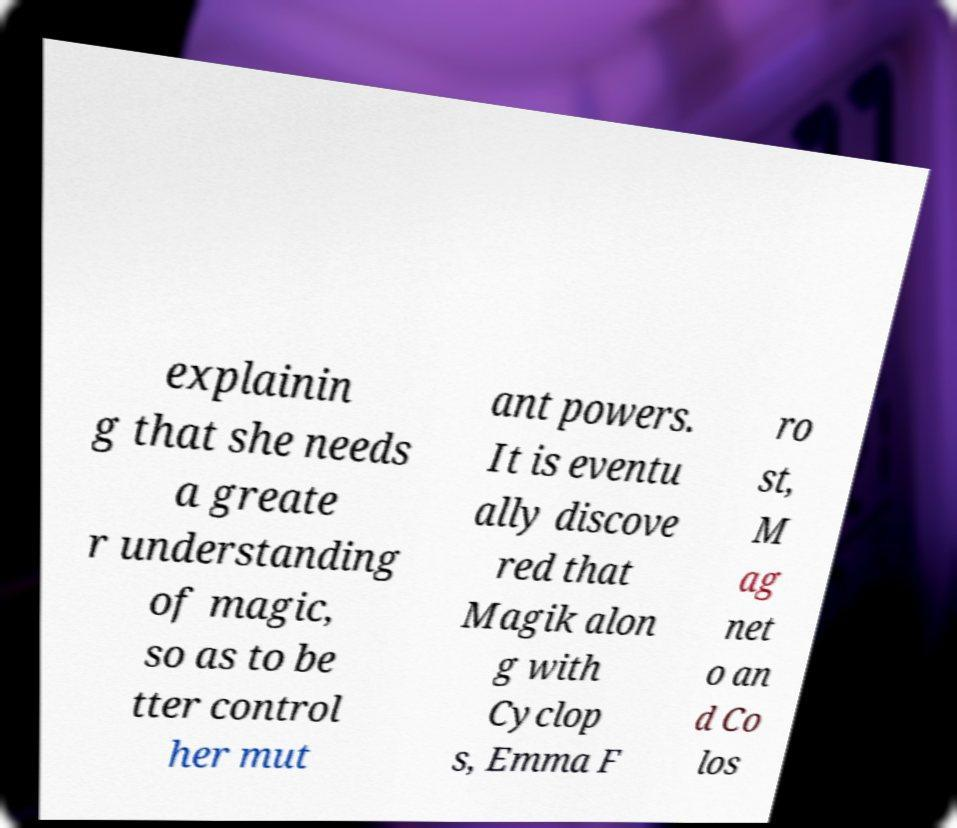I need the written content from this picture converted into text. Can you do that? explainin g that she needs a greate r understanding of magic, so as to be tter control her mut ant powers. It is eventu ally discove red that Magik alon g with Cyclop s, Emma F ro st, M ag net o an d Co los 